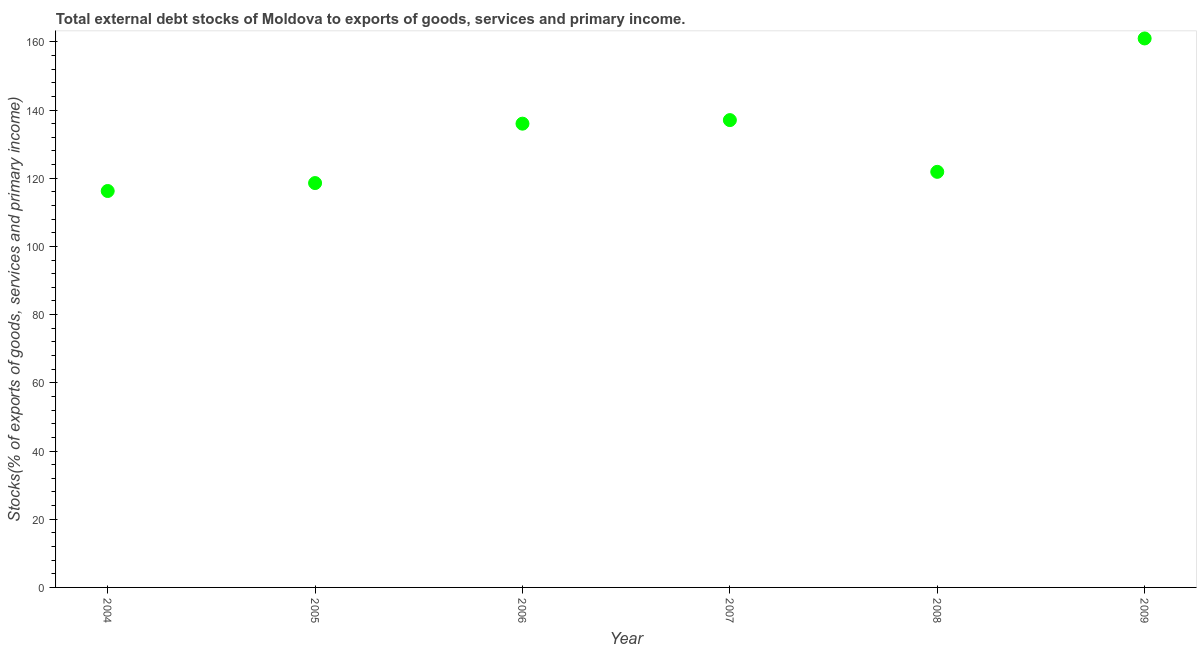What is the external debt stocks in 2005?
Your answer should be compact. 118.58. Across all years, what is the maximum external debt stocks?
Your answer should be very brief. 160.99. Across all years, what is the minimum external debt stocks?
Ensure brevity in your answer.  116.26. In which year was the external debt stocks minimum?
Offer a terse response. 2004. What is the sum of the external debt stocks?
Provide a succinct answer. 790.77. What is the difference between the external debt stocks in 2008 and 2009?
Give a very brief answer. -39.12. What is the average external debt stocks per year?
Provide a short and direct response. 131.79. What is the median external debt stocks?
Your answer should be very brief. 128.94. What is the ratio of the external debt stocks in 2006 to that in 2007?
Give a very brief answer. 0.99. Is the external debt stocks in 2007 less than that in 2008?
Your answer should be very brief. No. What is the difference between the highest and the second highest external debt stocks?
Ensure brevity in your answer.  23.94. What is the difference between the highest and the lowest external debt stocks?
Offer a very short reply. 44.74. In how many years, is the external debt stocks greater than the average external debt stocks taken over all years?
Give a very brief answer. 3. How many years are there in the graph?
Offer a very short reply. 6. What is the difference between two consecutive major ticks on the Y-axis?
Offer a terse response. 20. Does the graph contain any zero values?
Give a very brief answer. No. Does the graph contain grids?
Your answer should be compact. No. What is the title of the graph?
Your answer should be very brief. Total external debt stocks of Moldova to exports of goods, services and primary income. What is the label or title of the X-axis?
Ensure brevity in your answer.  Year. What is the label or title of the Y-axis?
Offer a very short reply. Stocks(% of exports of goods, services and primary income). What is the Stocks(% of exports of goods, services and primary income) in 2004?
Offer a terse response. 116.26. What is the Stocks(% of exports of goods, services and primary income) in 2005?
Offer a very short reply. 118.58. What is the Stocks(% of exports of goods, services and primary income) in 2006?
Ensure brevity in your answer.  136. What is the Stocks(% of exports of goods, services and primary income) in 2007?
Provide a short and direct response. 137.05. What is the Stocks(% of exports of goods, services and primary income) in 2008?
Ensure brevity in your answer.  121.88. What is the Stocks(% of exports of goods, services and primary income) in 2009?
Provide a short and direct response. 160.99. What is the difference between the Stocks(% of exports of goods, services and primary income) in 2004 and 2005?
Offer a terse response. -2.33. What is the difference between the Stocks(% of exports of goods, services and primary income) in 2004 and 2006?
Keep it short and to the point. -19.75. What is the difference between the Stocks(% of exports of goods, services and primary income) in 2004 and 2007?
Ensure brevity in your answer.  -20.79. What is the difference between the Stocks(% of exports of goods, services and primary income) in 2004 and 2008?
Give a very brief answer. -5.62. What is the difference between the Stocks(% of exports of goods, services and primary income) in 2004 and 2009?
Provide a short and direct response. -44.74. What is the difference between the Stocks(% of exports of goods, services and primary income) in 2005 and 2006?
Offer a terse response. -17.42. What is the difference between the Stocks(% of exports of goods, services and primary income) in 2005 and 2007?
Your answer should be very brief. -18.46. What is the difference between the Stocks(% of exports of goods, services and primary income) in 2005 and 2008?
Your answer should be very brief. -3.29. What is the difference between the Stocks(% of exports of goods, services and primary income) in 2005 and 2009?
Provide a succinct answer. -42.41. What is the difference between the Stocks(% of exports of goods, services and primary income) in 2006 and 2007?
Provide a short and direct response. -1.05. What is the difference between the Stocks(% of exports of goods, services and primary income) in 2006 and 2008?
Make the answer very short. 14.13. What is the difference between the Stocks(% of exports of goods, services and primary income) in 2006 and 2009?
Provide a short and direct response. -24.99. What is the difference between the Stocks(% of exports of goods, services and primary income) in 2007 and 2008?
Make the answer very short. 15.17. What is the difference between the Stocks(% of exports of goods, services and primary income) in 2007 and 2009?
Provide a succinct answer. -23.94. What is the difference between the Stocks(% of exports of goods, services and primary income) in 2008 and 2009?
Your answer should be very brief. -39.12. What is the ratio of the Stocks(% of exports of goods, services and primary income) in 2004 to that in 2006?
Provide a succinct answer. 0.85. What is the ratio of the Stocks(% of exports of goods, services and primary income) in 2004 to that in 2007?
Give a very brief answer. 0.85. What is the ratio of the Stocks(% of exports of goods, services and primary income) in 2004 to that in 2008?
Give a very brief answer. 0.95. What is the ratio of the Stocks(% of exports of goods, services and primary income) in 2004 to that in 2009?
Ensure brevity in your answer.  0.72. What is the ratio of the Stocks(% of exports of goods, services and primary income) in 2005 to that in 2006?
Give a very brief answer. 0.87. What is the ratio of the Stocks(% of exports of goods, services and primary income) in 2005 to that in 2007?
Give a very brief answer. 0.86. What is the ratio of the Stocks(% of exports of goods, services and primary income) in 2005 to that in 2008?
Ensure brevity in your answer.  0.97. What is the ratio of the Stocks(% of exports of goods, services and primary income) in 2005 to that in 2009?
Keep it short and to the point. 0.74. What is the ratio of the Stocks(% of exports of goods, services and primary income) in 2006 to that in 2008?
Keep it short and to the point. 1.12. What is the ratio of the Stocks(% of exports of goods, services and primary income) in 2006 to that in 2009?
Ensure brevity in your answer.  0.84. What is the ratio of the Stocks(% of exports of goods, services and primary income) in 2007 to that in 2009?
Provide a succinct answer. 0.85. What is the ratio of the Stocks(% of exports of goods, services and primary income) in 2008 to that in 2009?
Give a very brief answer. 0.76. 